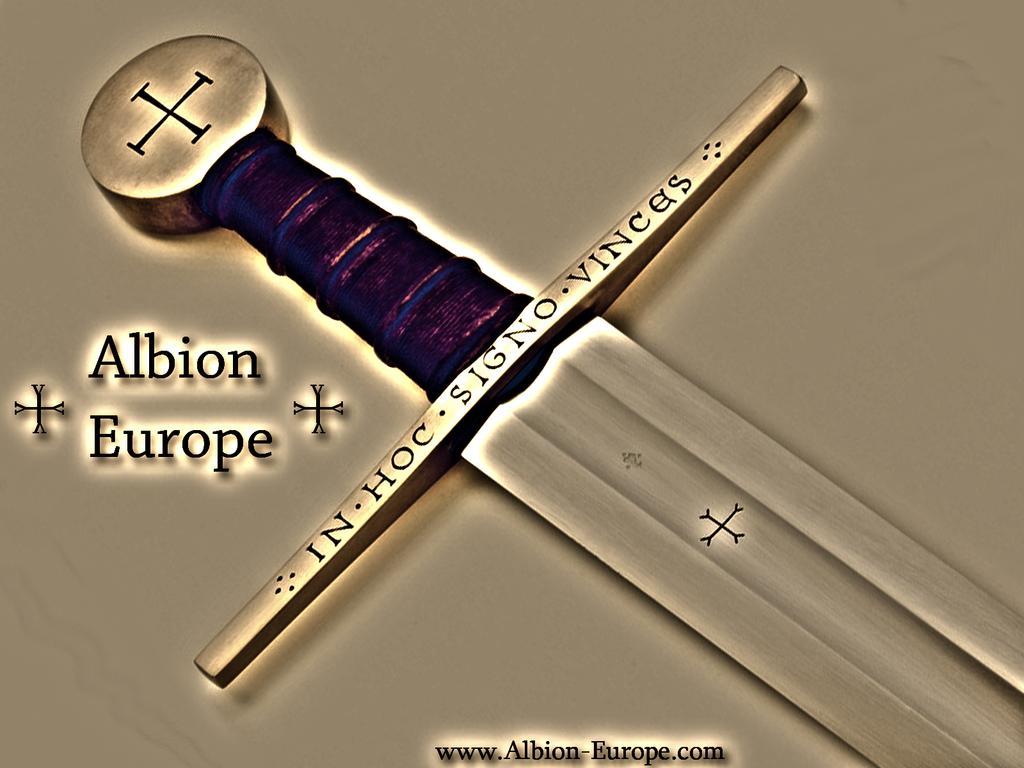In one or two sentences, can you explain what this image depicts? In this image in the center there is a sword, and on the sword there is some text and on the right side. And at the bottom of the image there is some text. 